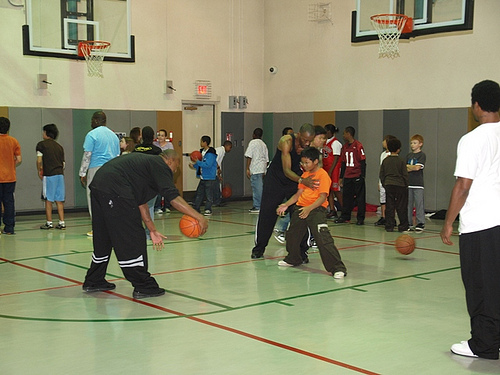<image>
Can you confirm if the basketball is on the floor? No. The basketball is not positioned on the floor. They may be near each other, but the basketball is not supported by or resting on top of the floor. Where is the ball in relation to the boy? Is it under the boy? No. The ball is not positioned under the boy. The vertical relationship between these objects is different. 